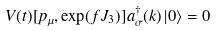<formula> <loc_0><loc_0><loc_500><loc_500>V ( t ) [ p _ { \mu } , \exp ( f J _ { 3 } ) ] a _ { \sigma } ^ { \dagger } ( k ) \left | 0 \right \rangle = 0</formula> 